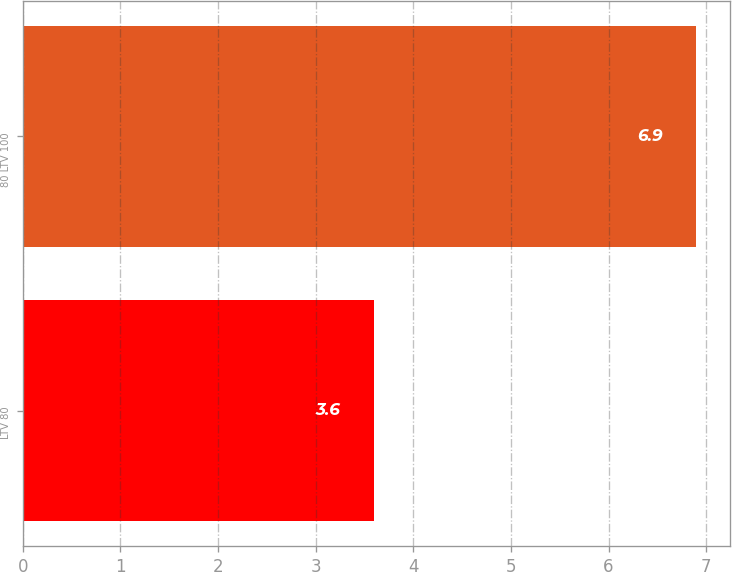Convert chart. <chart><loc_0><loc_0><loc_500><loc_500><bar_chart><fcel>LTV 80<fcel>80 LTV 100<nl><fcel>3.6<fcel>6.9<nl></chart> 